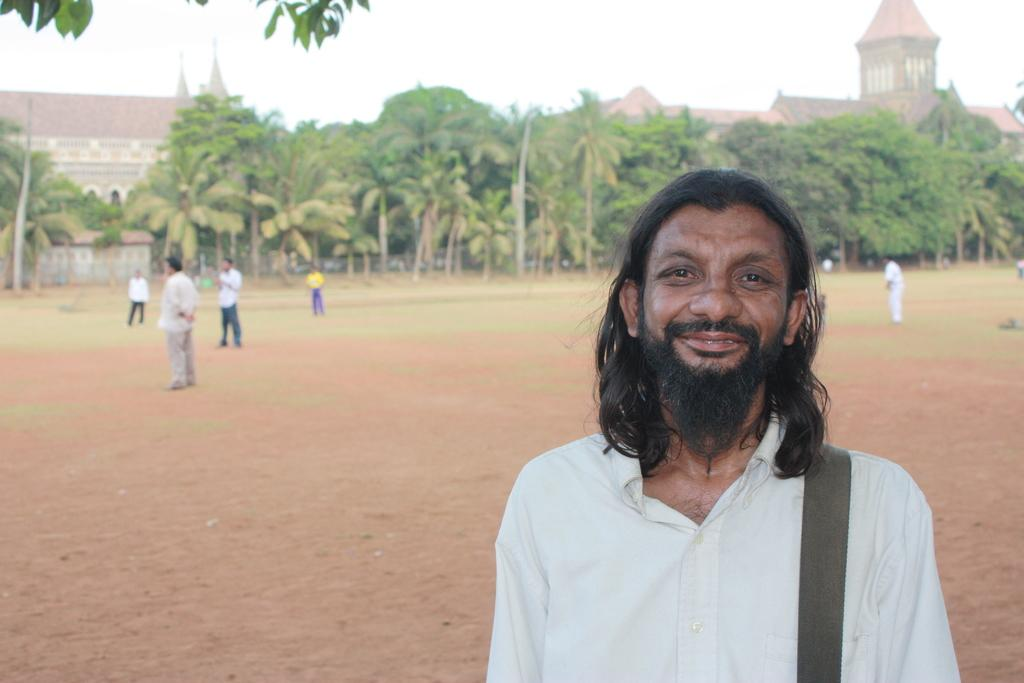Who or what is present in the image? There are people in the image. What can be seen beneath the people's feet? The ground is visible in the image. What type of vegetation is present in the image? There is grass in the image. What else can be seen in the background of the image? There are trees in the image. What is visible above the people and trees? The sky is visible in the image. How many legs does the sheep have in the image? There is no sheep present in the image. 